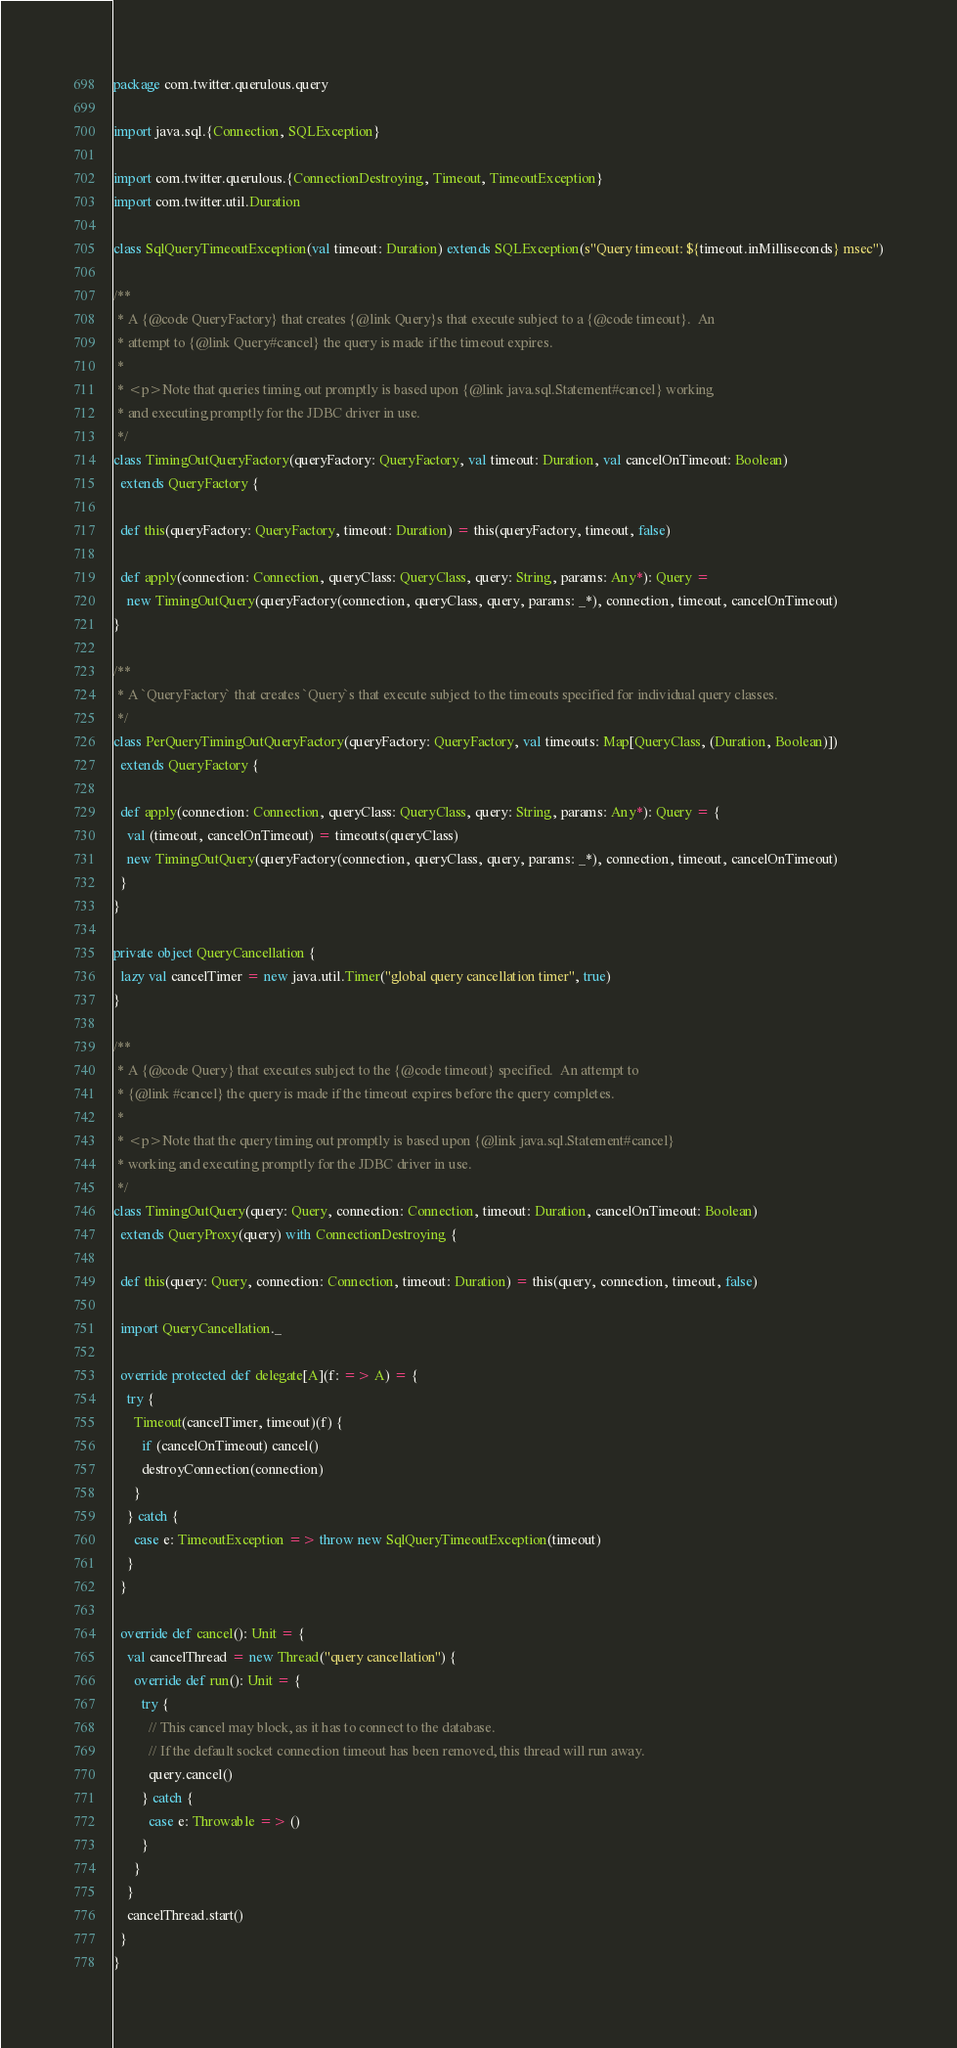<code> <loc_0><loc_0><loc_500><loc_500><_Scala_>package com.twitter.querulous.query

import java.sql.{Connection, SQLException}

import com.twitter.querulous.{ConnectionDestroying, Timeout, TimeoutException}
import com.twitter.util.Duration

class SqlQueryTimeoutException(val timeout: Duration) extends SQLException(s"Query timeout: ${timeout.inMilliseconds} msec")

/**
 * A {@code QueryFactory} that creates {@link Query}s that execute subject to a {@code timeout}.  An
 * attempt to {@link Query#cancel} the query is made if the timeout expires.
 *
 * <p>Note that queries timing out promptly is based upon {@link java.sql.Statement#cancel} working
 * and executing promptly for the JDBC driver in use.
 */
class TimingOutQueryFactory(queryFactory: QueryFactory, val timeout: Duration, val cancelOnTimeout: Boolean)
  extends QueryFactory {

  def this(queryFactory: QueryFactory, timeout: Duration) = this(queryFactory, timeout, false)

  def apply(connection: Connection, queryClass: QueryClass, query: String, params: Any*): Query =
    new TimingOutQuery(queryFactory(connection, queryClass, query, params: _*), connection, timeout, cancelOnTimeout)
}

/**
 * A `QueryFactory` that creates `Query`s that execute subject to the timeouts specified for individual query classes.
 */
class PerQueryTimingOutQueryFactory(queryFactory: QueryFactory, val timeouts: Map[QueryClass, (Duration, Boolean)])
  extends QueryFactory {

  def apply(connection: Connection, queryClass: QueryClass, query: String, params: Any*): Query = {
    val (timeout, cancelOnTimeout) = timeouts(queryClass)
    new TimingOutQuery(queryFactory(connection, queryClass, query, params: _*), connection, timeout, cancelOnTimeout)
  }
}

private object QueryCancellation {
  lazy val cancelTimer = new java.util.Timer("global query cancellation timer", true)
}

/**
 * A {@code Query} that executes subject to the {@code timeout} specified.  An attempt to
 * {@link #cancel} the query is made if the timeout expires before the query completes.
 *
 * <p>Note that the query timing out promptly is based upon {@link java.sql.Statement#cancel}
 * working and executing promptly for the JDBC driver in use.
 */
class TimingOutQuery(query: Query, connection: Connection, timeout: Duration, cancelOnTimeout: Boolean)
  extends QueryProxy(query) with ConnectionDestroying {

  def this(query: Query, connection: Connection, timeout: Duration) = this(query, connection, timeout, false)

  import QueryCancellation._

  override protected def delegate[A](f: => A) = {
    try {
      Timeout(cancelTimer, timeout)(f) {
        if (cancelOnTimeout) cancel()
        destroyConnection(connection)
      }
    } catch {
      case e: TimeoutException => throw new SqlQueryTimeoutException(timeout)
    }
  }

  override def cancel(): Unit = {
    val cancelThread = new Thread("query cancellation") {
      override def run(): Unit = {
        try {
          // This cancel may block, as it has to connect to the database.
          // If the default socket connection timeout has been removed, this thread will run away.
          query.cancel()
        } catch {
          case e: Throwable => ()
        }
      }
    }
    cancelThread.start()
  }
}
</code> 